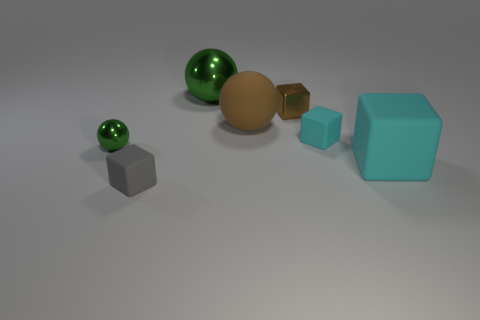Add 2 big green metallic balls. How many objects exist? 9 Subtract all balls. How many objects are left? 4 Add 1 tiny gray rubber cubes. How many tiny gray rubber cubes exist? 2 Subtract 0 blue cubes. How many objects are left? 7 Subtract all small green shiny balls. Subtract all big cylinders. How many objects are left? 6 Add 6 big cubes. How many big cubes are left? 7 